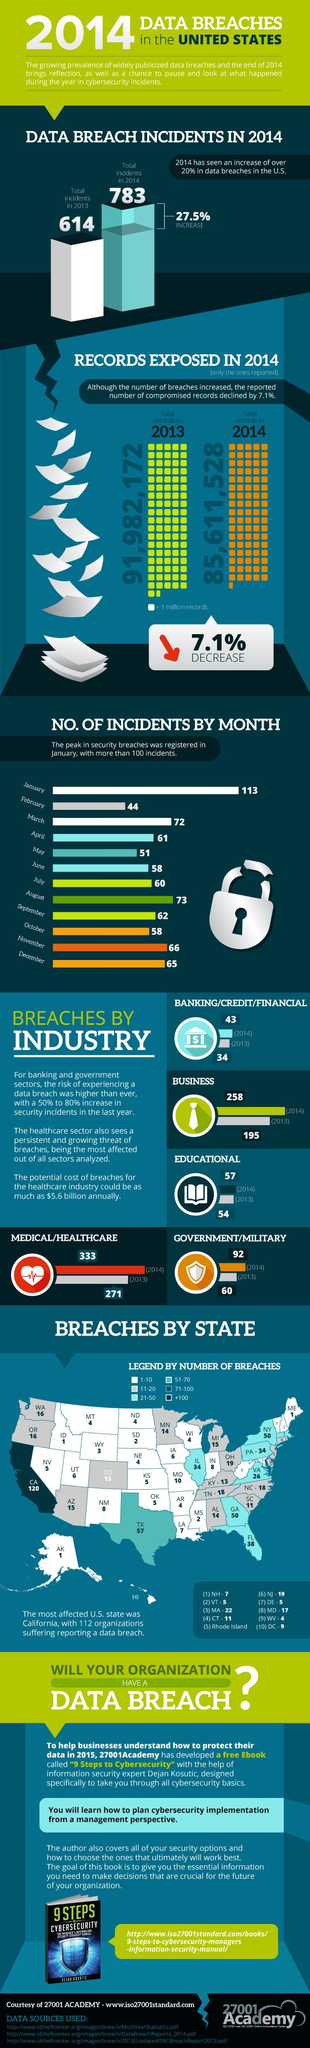List a handful of essential elements in this visual. In 2013, there were more reported instances of data breaches than in any other year. In February, the number of incidents reported was below 50, making it the only month to meet this criteria. In 2014, 92 data breach incidents were reported by the government/military. In 2014, the medical/healthcare sector reported 333 data breach incidents. Of the states, how many have reported more than 51 data breach incidents? 